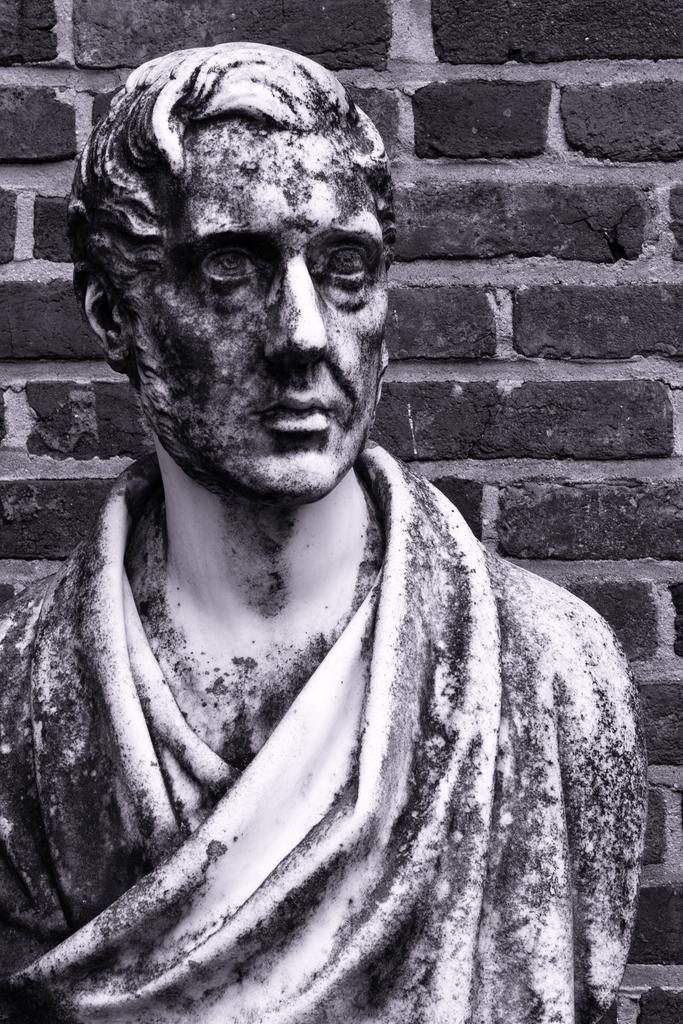What is the main subject of the image? There is a sculpture of a person in the image. What can be seen in the background of the image? There is a brick wall in the background of the image. What type of leather treatment is being applied to the friends in the image? There are no friends or leather treatment present in the image; it features a sculpture of a person and a brick wall in the background. 